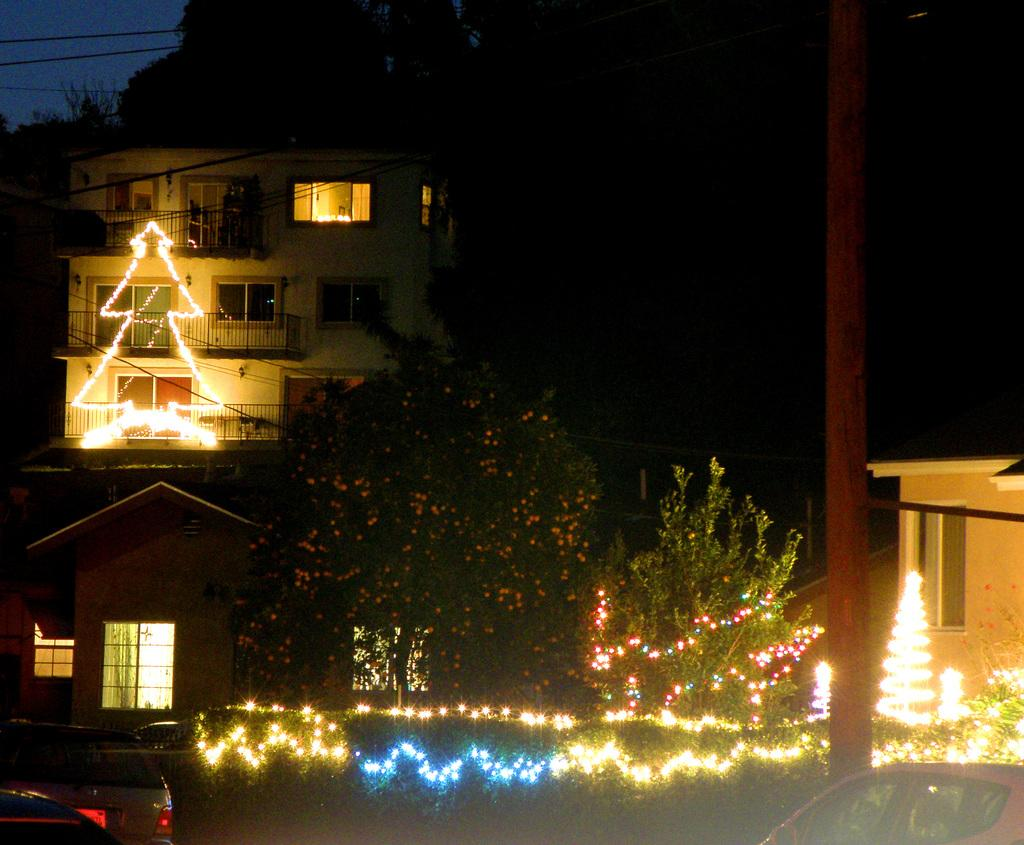What type of structures can be seen in the image? There are houses in the image. What type of natural elements are present in the image? There are trees and plants in the image. What is unique about the plants in the image? There are lights visible on the plants. What type of man-made objects can be seen in the image? There are vehicles parked in the image. What role does the actor play in the image? There is no actor present in the image. How does the duck interact with the houses in the image? There is no duck present in the image. 